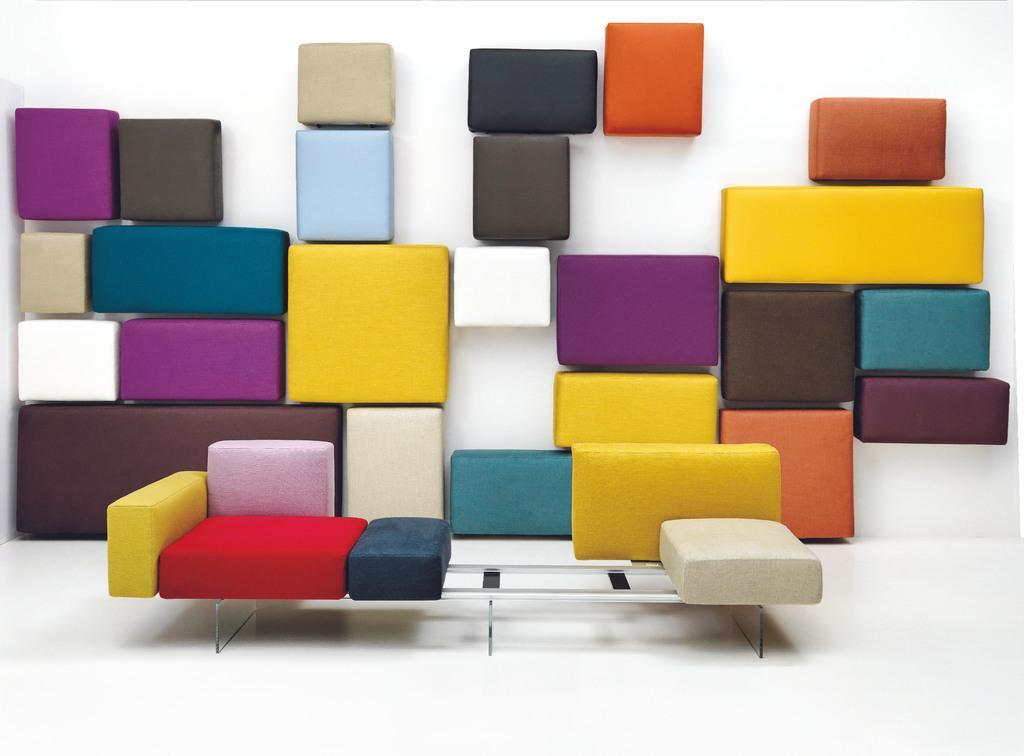Can you describe this image briefly? In this image we can see boxes arranged in random rows. 